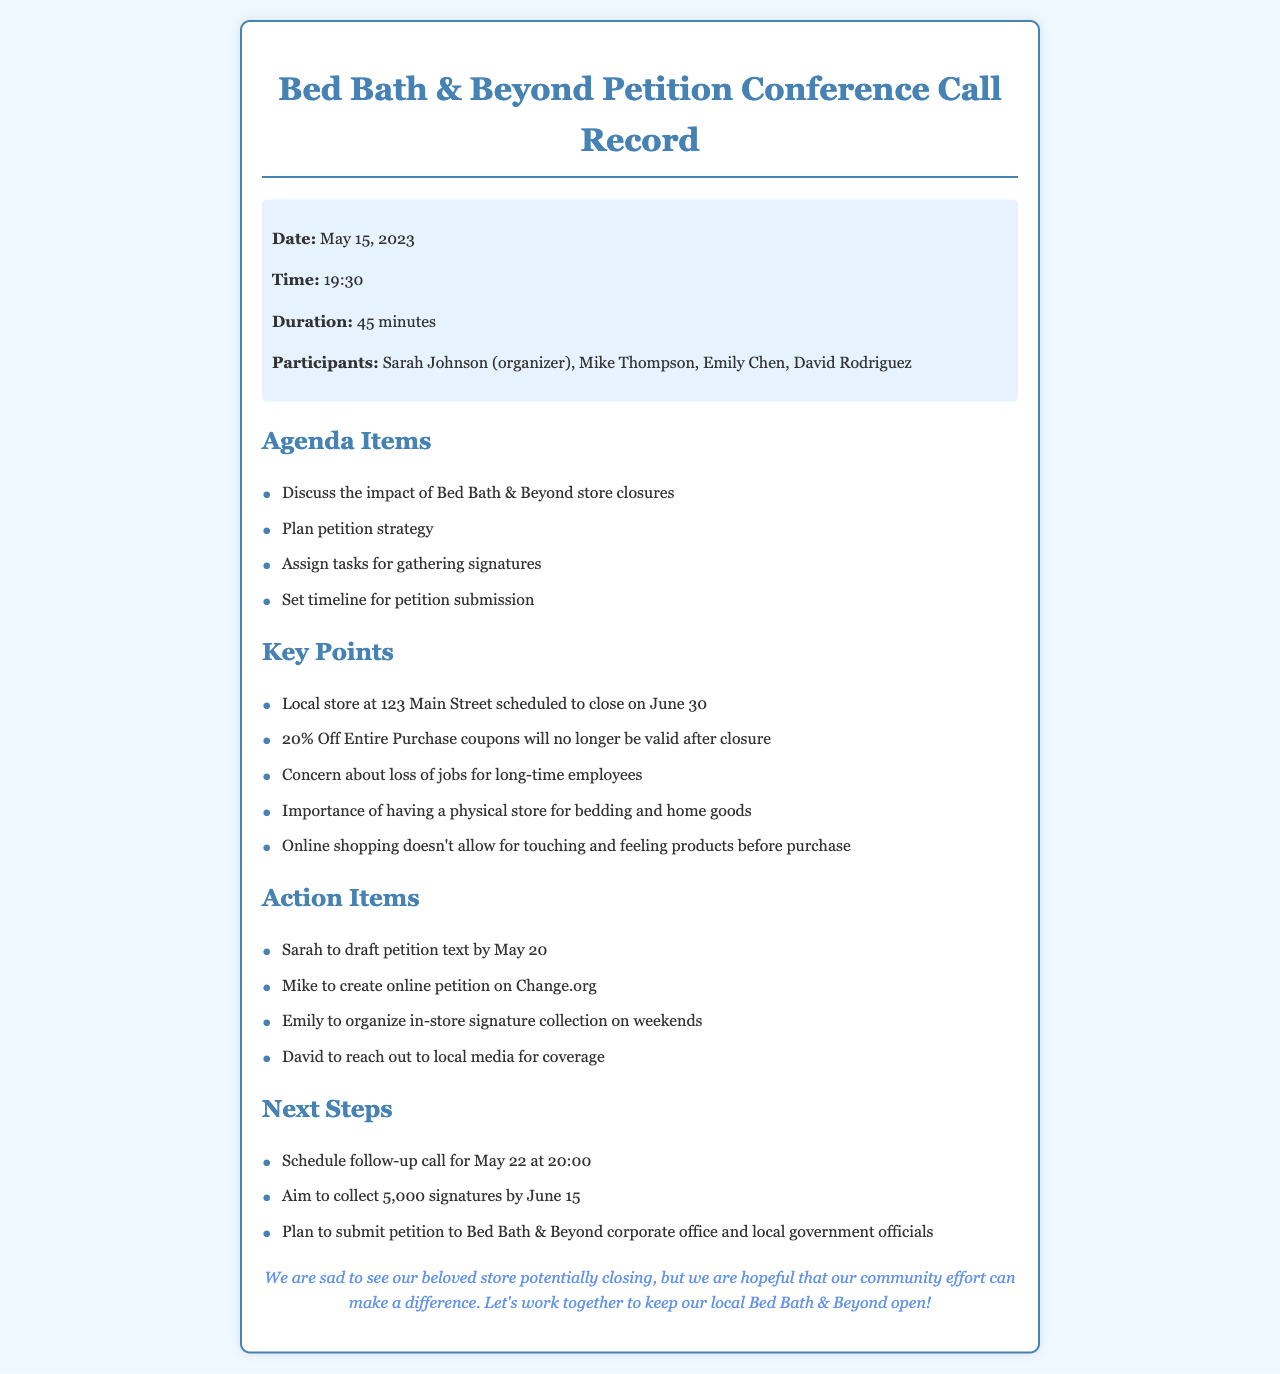What is the date of the conference call? The date of the conference call is stated in the call details section.
Answer: May 15, 2023 Who is the organizer of the call? The organizer of the conference call is mentioned in the participants list.
Answer: Sarah Johnson What is the duration of the call? The duration is specified in the call details section.
Answer: 45 minutes What task is Mike responsible for? Mike's responsibility is outlined in the action items section of the document.
Answer: Create online petition on Change.org What is the plan for the signature collection? The plan for gathering signatures is detailed in the action items section.
Answer: Organize in-store signature collection on weekends How many signatures do they aim to collect? This goal is outlined in the next steps section of the document.
Answer: 5,000 signatures What is a concern discussed in the call regarding the store closure? Concerns mentioned in key points regarding the closure include a loss of jobs.
Answer: Loss of jobs for long-time employees What is the significance of having a physical store mentioned in the call? The importance of a physical store is discussed in the key points section.
Answer: Touching and feeling products before purchase What is the next scheduled call date? The next scheduled call date is mentioned in the next steps section.
Answer: May 22 at 20:00 